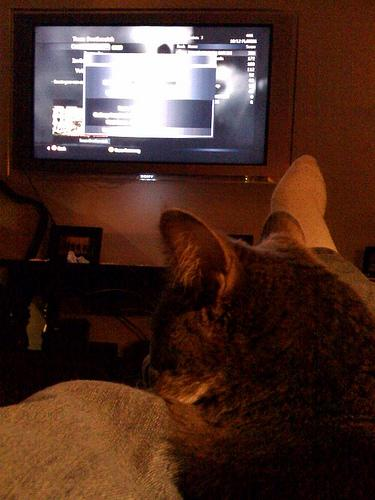What is the person doing in the bed? Please explain your reasoning. watching television. Based on the location and orientation of the person's foot, from this perspective the rest of their body would be facing towards the television. 